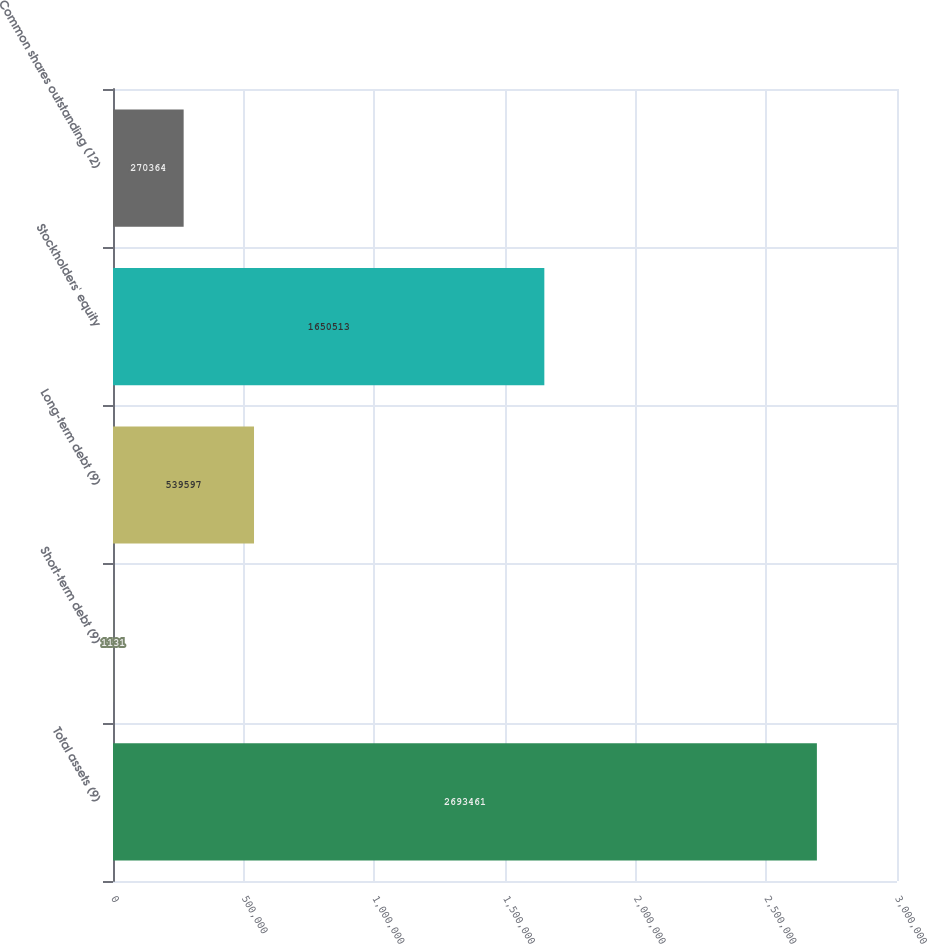Convert chart to OTSL. <chart><loc_0><loc_0><loc_500><loc_500><bar_chart><fcel>Total assets (9)<fcel>Short-term debt (9)<fcel>Long-term debt (9)<fcel>Stockholders' equity<fcel>Common shares outstanding (12)<nl><fcel>2.69346e+06<fcel>1131<fcel>539597<fcel>1.65051e+06<fcel>270364<nl></chart> 